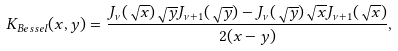<formula> <loc_0><loc_0><loc_500><loc_500>K _ { B e s s e l } ( x , y ) = \frac { J _ { \nu } ( \sqrt { x } ) \sqrt { y } J _ { \nu + 1 } ( \sqrt { y } ) - J _ { \nu } ( \sqrt { y } ) \sqrt { x } J _ { \nu + 1 } ( \sqrt { x } ) } { 2 ( x - y ) } ,</formula> 